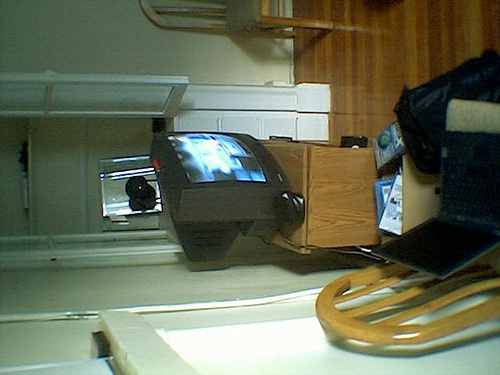Describe the objects in this image and their specific colors. I can see chair in darkgreen, olive, gray, and black tones, tv in darkgreen, black, and lightblue tones, laptop in darkgreen, black, and olive tones, and chair in darkgreen and black tones in this image. 